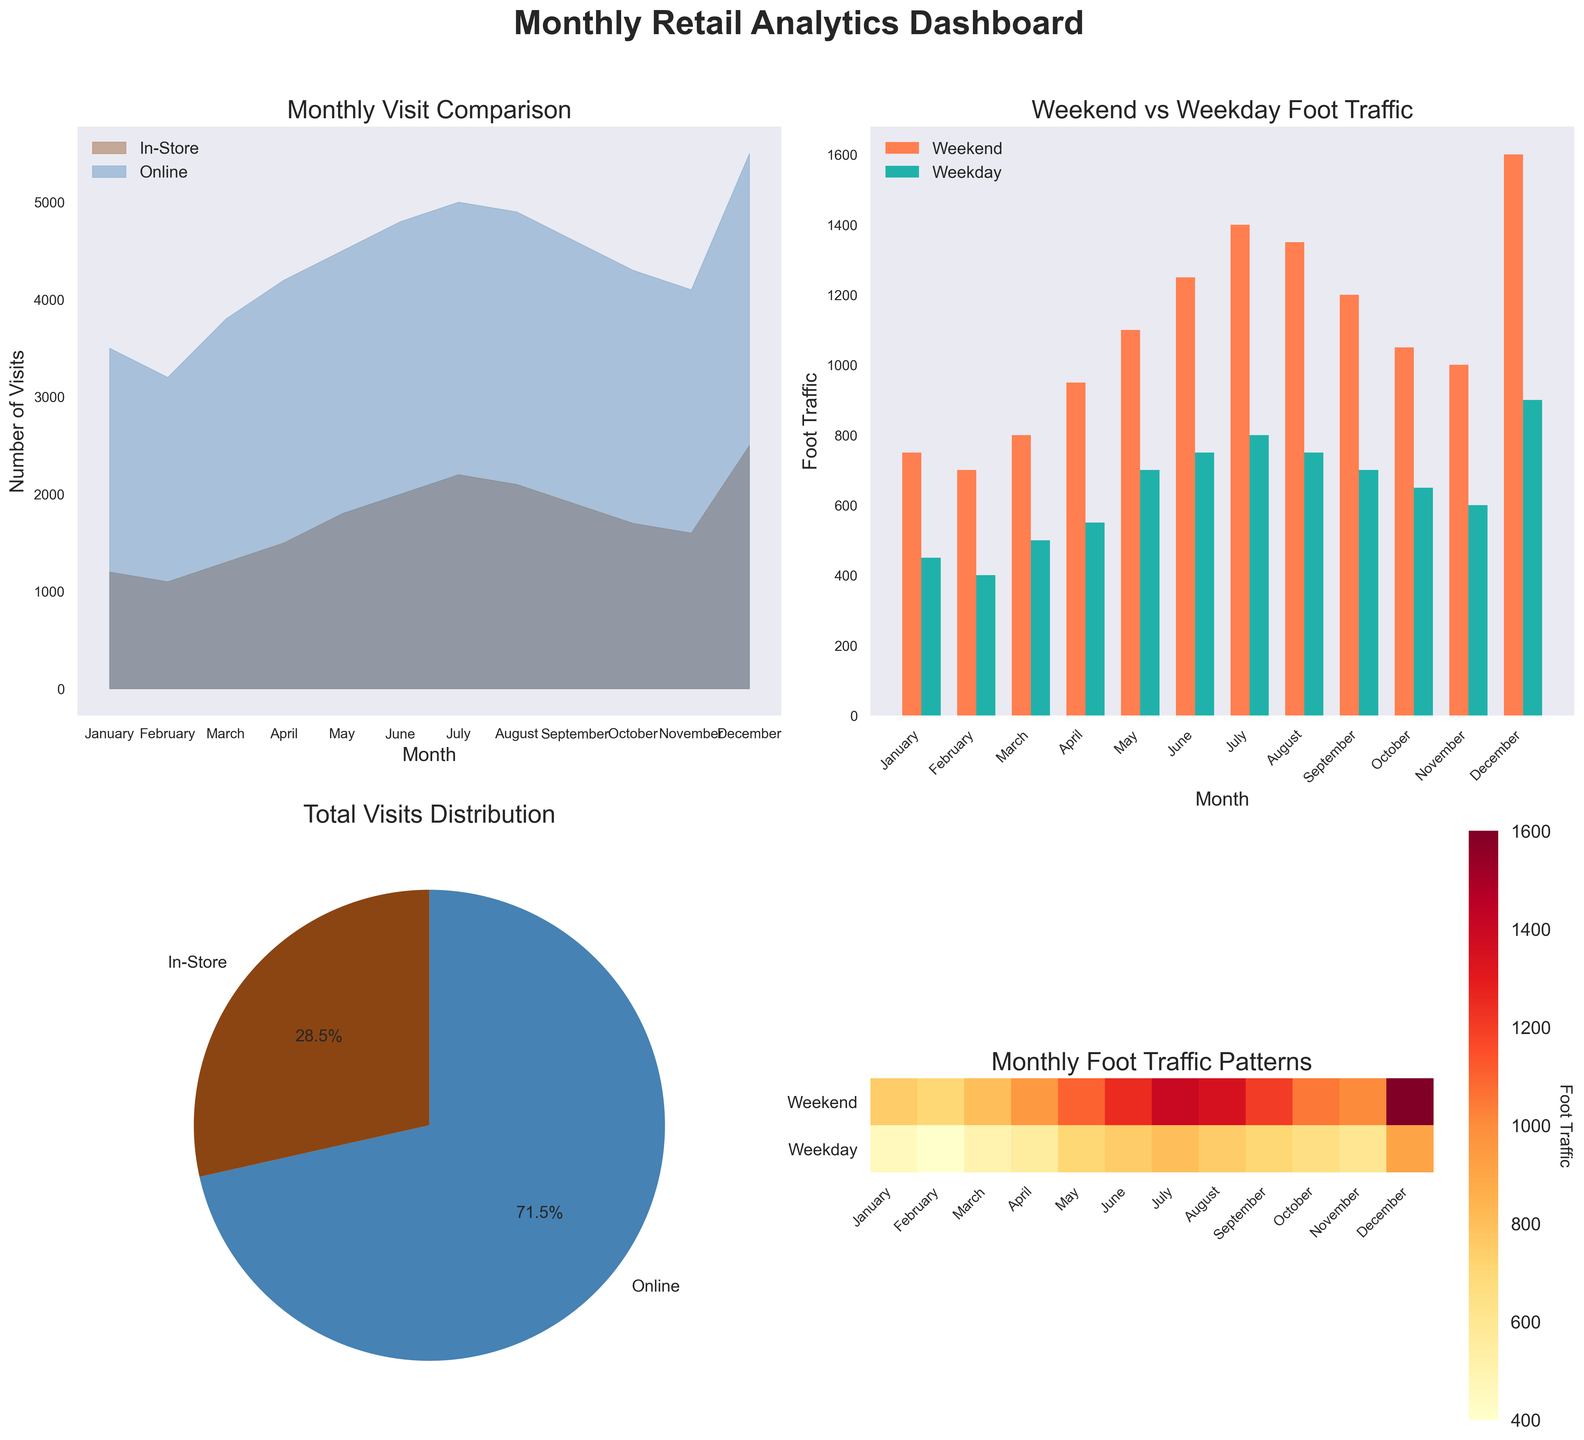What is the title of the area chart in the top-left corner? The area chart in the top-left corner has the title "Monthly Visit Comparison" which is displayed prominently above the chart.
Answer: Monthly Visit Comparison What are the labels of the pie chart wedges in the bottom-left corner? The pie chart in the bottom-left corner contains two wedges with labels "In-Store" and "Online". These labels are displayed next to each corresponding wedge.
Answer: In-Store, Online Which month has the highest foot traffic on the weekends? In the bar chart in the top-right corner, the bar for December is the highest for weekend foot traffic. The height of the bar indicates that December has the highest weekend foot traffic.
Answer: December Which months have consistently more weekday foot traffic than weekend foot traffic? By comparing the height of the bars for weekday and weekend foot traffic in the bar chart in the top-right corner, all months show that weekday foot traffic is lower than weekend foot traffic, so no months consistently have more weekday traffic.
Answer: None What is the approximate proportion of total visits that are online? The pie chart in the bottom-left corner shows the distribution of total visits. It indicates that the "Online" category accounts for approximately 59.1% of total visits. This is obtained from the pie chart's display of proportions.
Answer: 59.1% What is the sum of in-store visits from January to June? Summing up the in-store visits from January (1200), February (1100), March (1300), April (1500), May (1800), and June (2000) gives a total of 8900.
Answer: 8900 Between July and December, which month has the lowest online visits? By observing the area chart in the top-left corner, December (5500) compared to other months in the second half of the year, September (4600) has the lowest online visits.
Answer: September Which month shows the largest discrepancy between weekend and weekday foot traffic? The bar chart in the top-right corner indicates that December has the largest difference between weekend and weekday foot traffic. The bars for December show a larger gap than other months.
Answer: December What is the color used to represent the 'Weekday' foot traffic in the heatmap? In the heatmap located in the bottom-right corner, 'Weekday' foot traffic is represented using a gradient of the color range from yellow to red as indicated by the heatmap legend.
Answer: Yellow to Red 